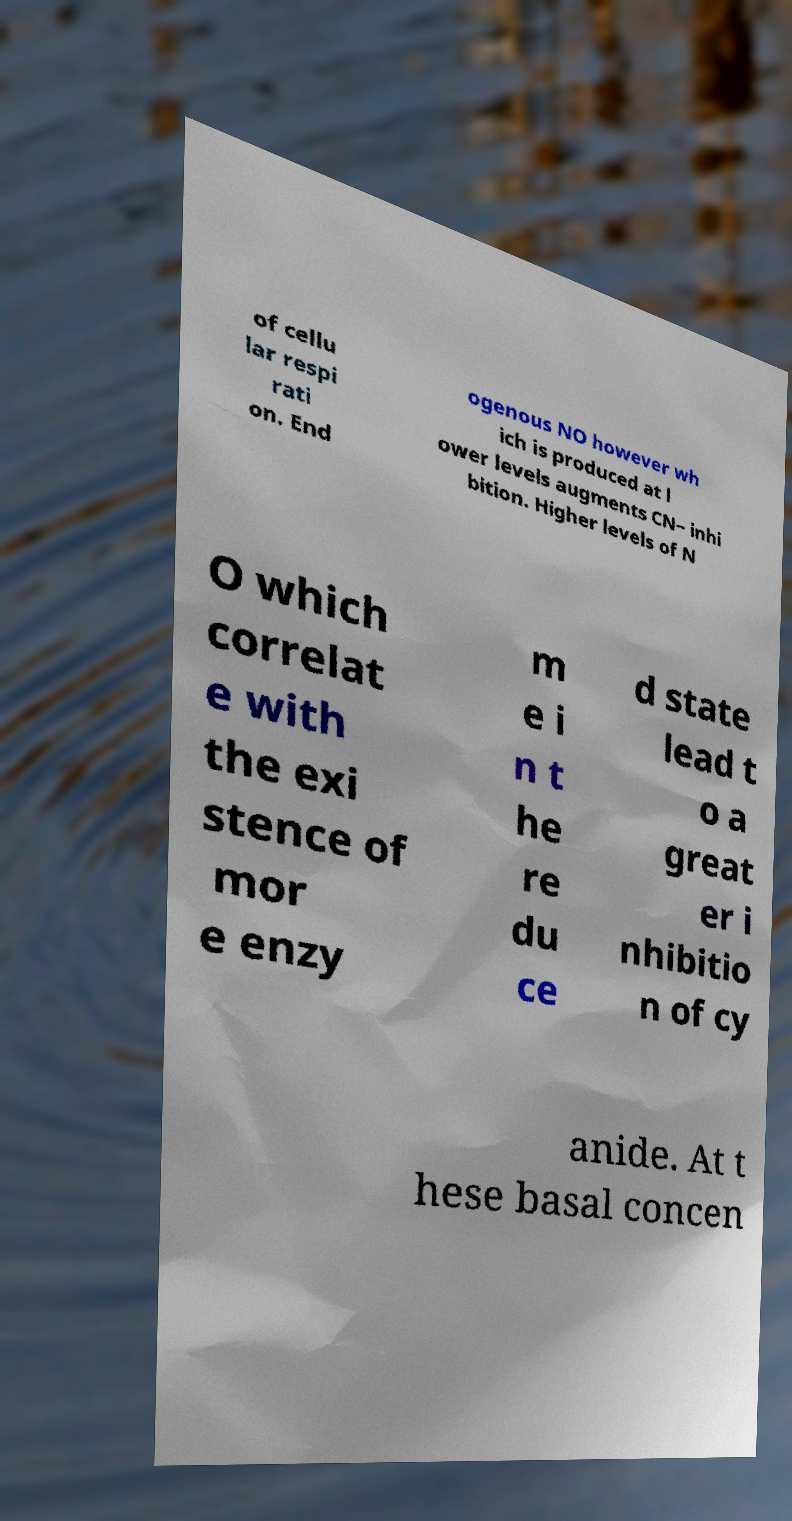What messages or text are displayed in this image? I need them in a readable, typed format. of cellu lar respi rati on. End ogenous NO however wh ich is produced at l ower levels augments CN− inhi bition. Higher levels of N O which correlat e with the exi stence of mor e enzy m e i n t he re du ce d state lead t o a great er i nhibitio n of cy anide. At t hese basal concen 